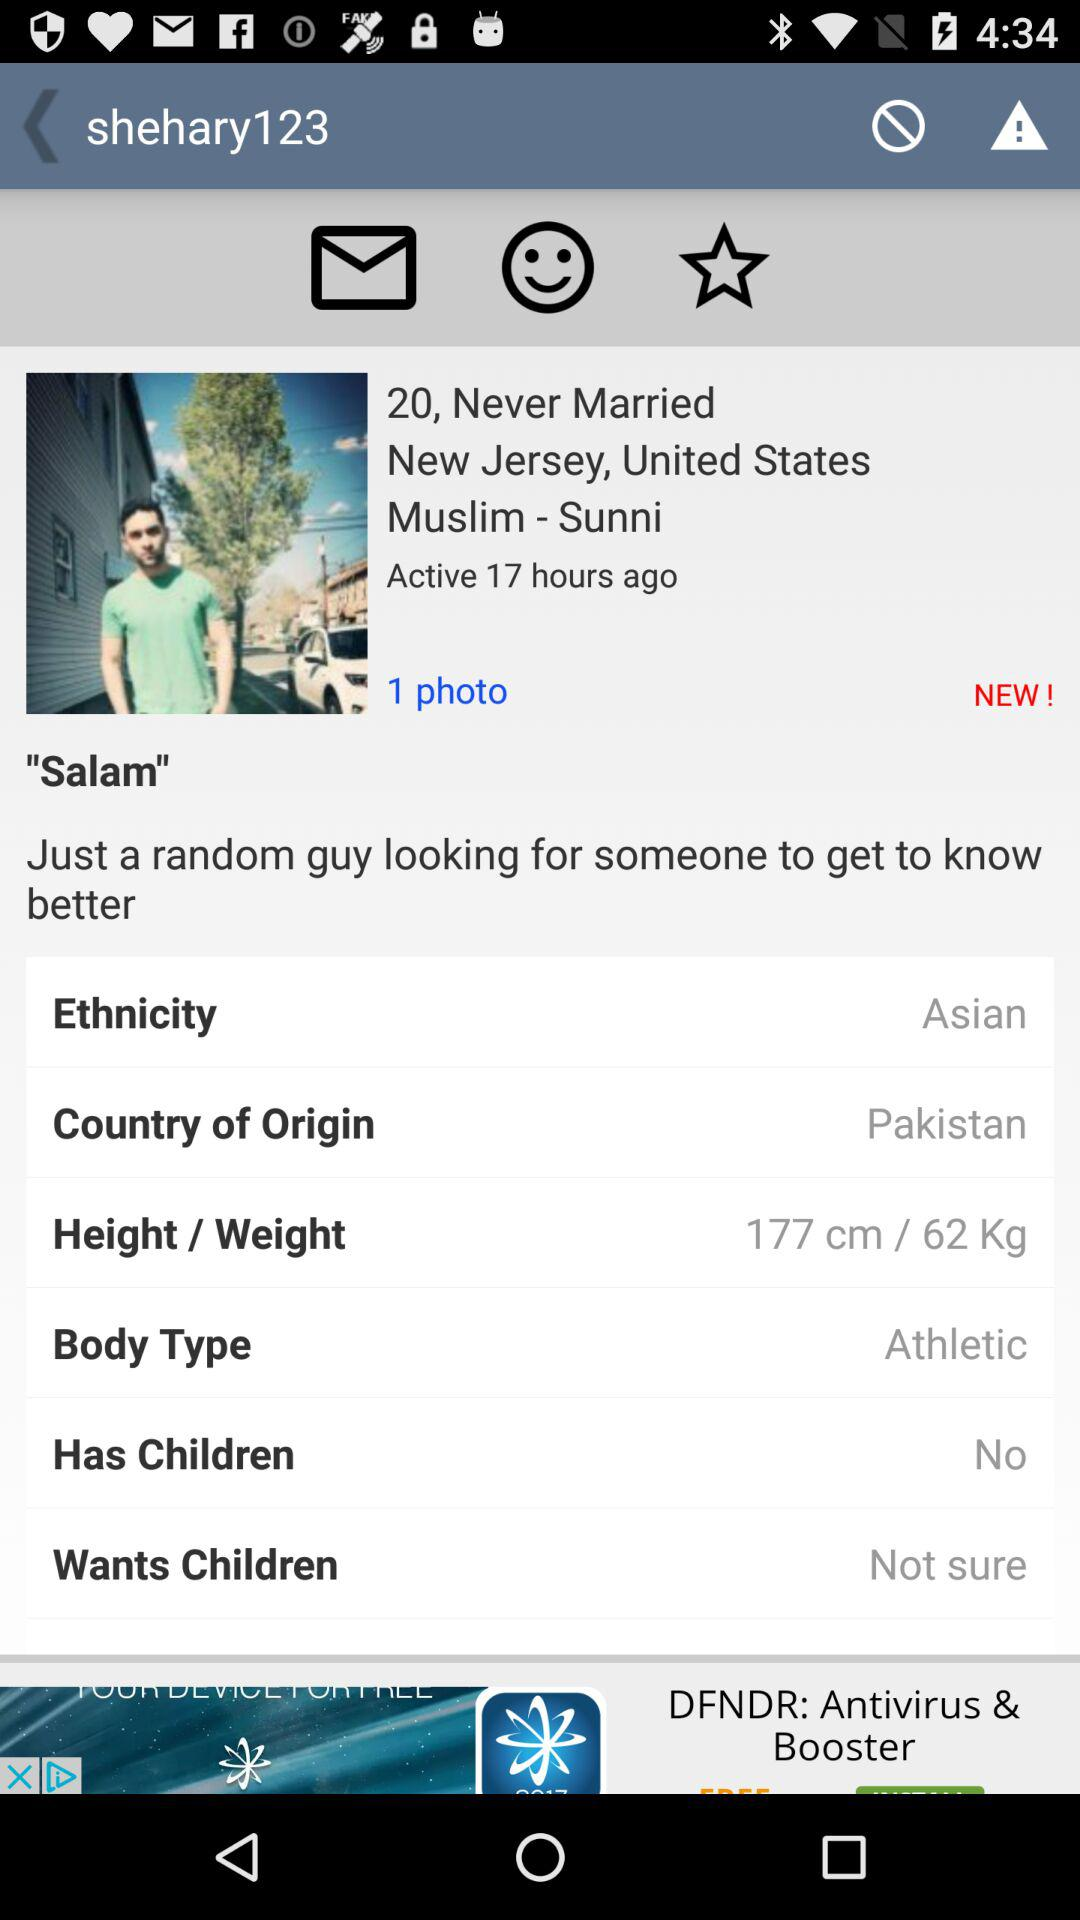What is the given height and weight? The given height and weight are 177 cm and 62 kg. 